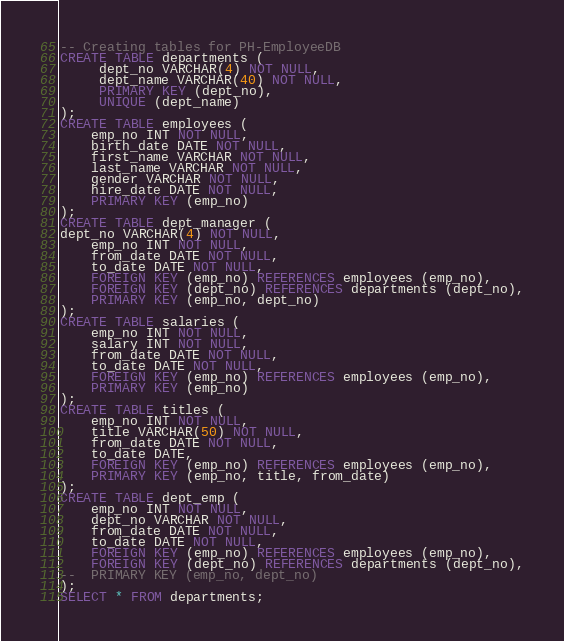Convert code to text. <code><loc_0><loc_0><loc_500><loc_500><_SQL_>-- Creating tables for PH-EmployeeDB
CREATE TABLE departments (
     dept_no VARCHAR(4) NOT NULL,
     dept_name VARCHAR(40) NOT NULL,
     PRIMARY KEY (dept_no),
     UNIQUE (dept_name)
);
CREATE TABLE employees (
	emp_no INT NOT NULL,
	birth_date DATE NOT NULL,
	first_name VARCHAR NOT NULL,
	last_name VARCHAR NOT NULL,
	gender VARCHAR NOT NULL,
	hire_date DATE NOT NULL,
	PRIMARY KEY (emp_no)
);
CREATE TABLE dept_manager (
dept_no VARCHAR(4) NOT NULL,
    emp_no INT NOT NULL,
    from_date DATE NOT NULL,
    to_date DATE NOT NULL,
    FOREIGN KEY (emp_no) REFERENCES employees (emp_no),
    FOREIGN KEY (dept_no) REFERENCES departments (dept_no),
    PRIMARY KEY (emp_no, dept_no)
);
CREATE TABLE salaries (
  	emp_no INT NOT NULL,
  	salary INT NOT NULL,
  	from_date DATE NOT NULL,
  	to_date DATE NOT NULL,
  	FOREIGN KEY (emp_no) REFERENCES employees (emp_no),
  	PRIMARY KEY (emp_no)
);
CREATE TABLE titles (
  	emp_no INT NOT NULL,
	title VARCHAR(50) NOT NULL,
  	from_date DATE NOT NULL,
  	to_date DATE,
  	FOREIGN KEY (emp_no) REFERENCES employees (emp_no),
	PRIMARY KEY (emp_no, title, from_date)
);
CREATE TABLE dept_emp (
  	emp_no INT NOT NULL,
  	dept_no VARCHAR NOT NULL,
	from_date DATE NOT NULL,
  	to_date DATE NOT NULL,
  	FOREIGN KEY (emp_no) REFERENCES employees (emp_no),
  	FOREIGN KEY (dept_no) REFERENCES departments (dept_no),
--	PRIMARY KEY (emp_no, dept_no)
);
SELECT * FROM departments;</code> 